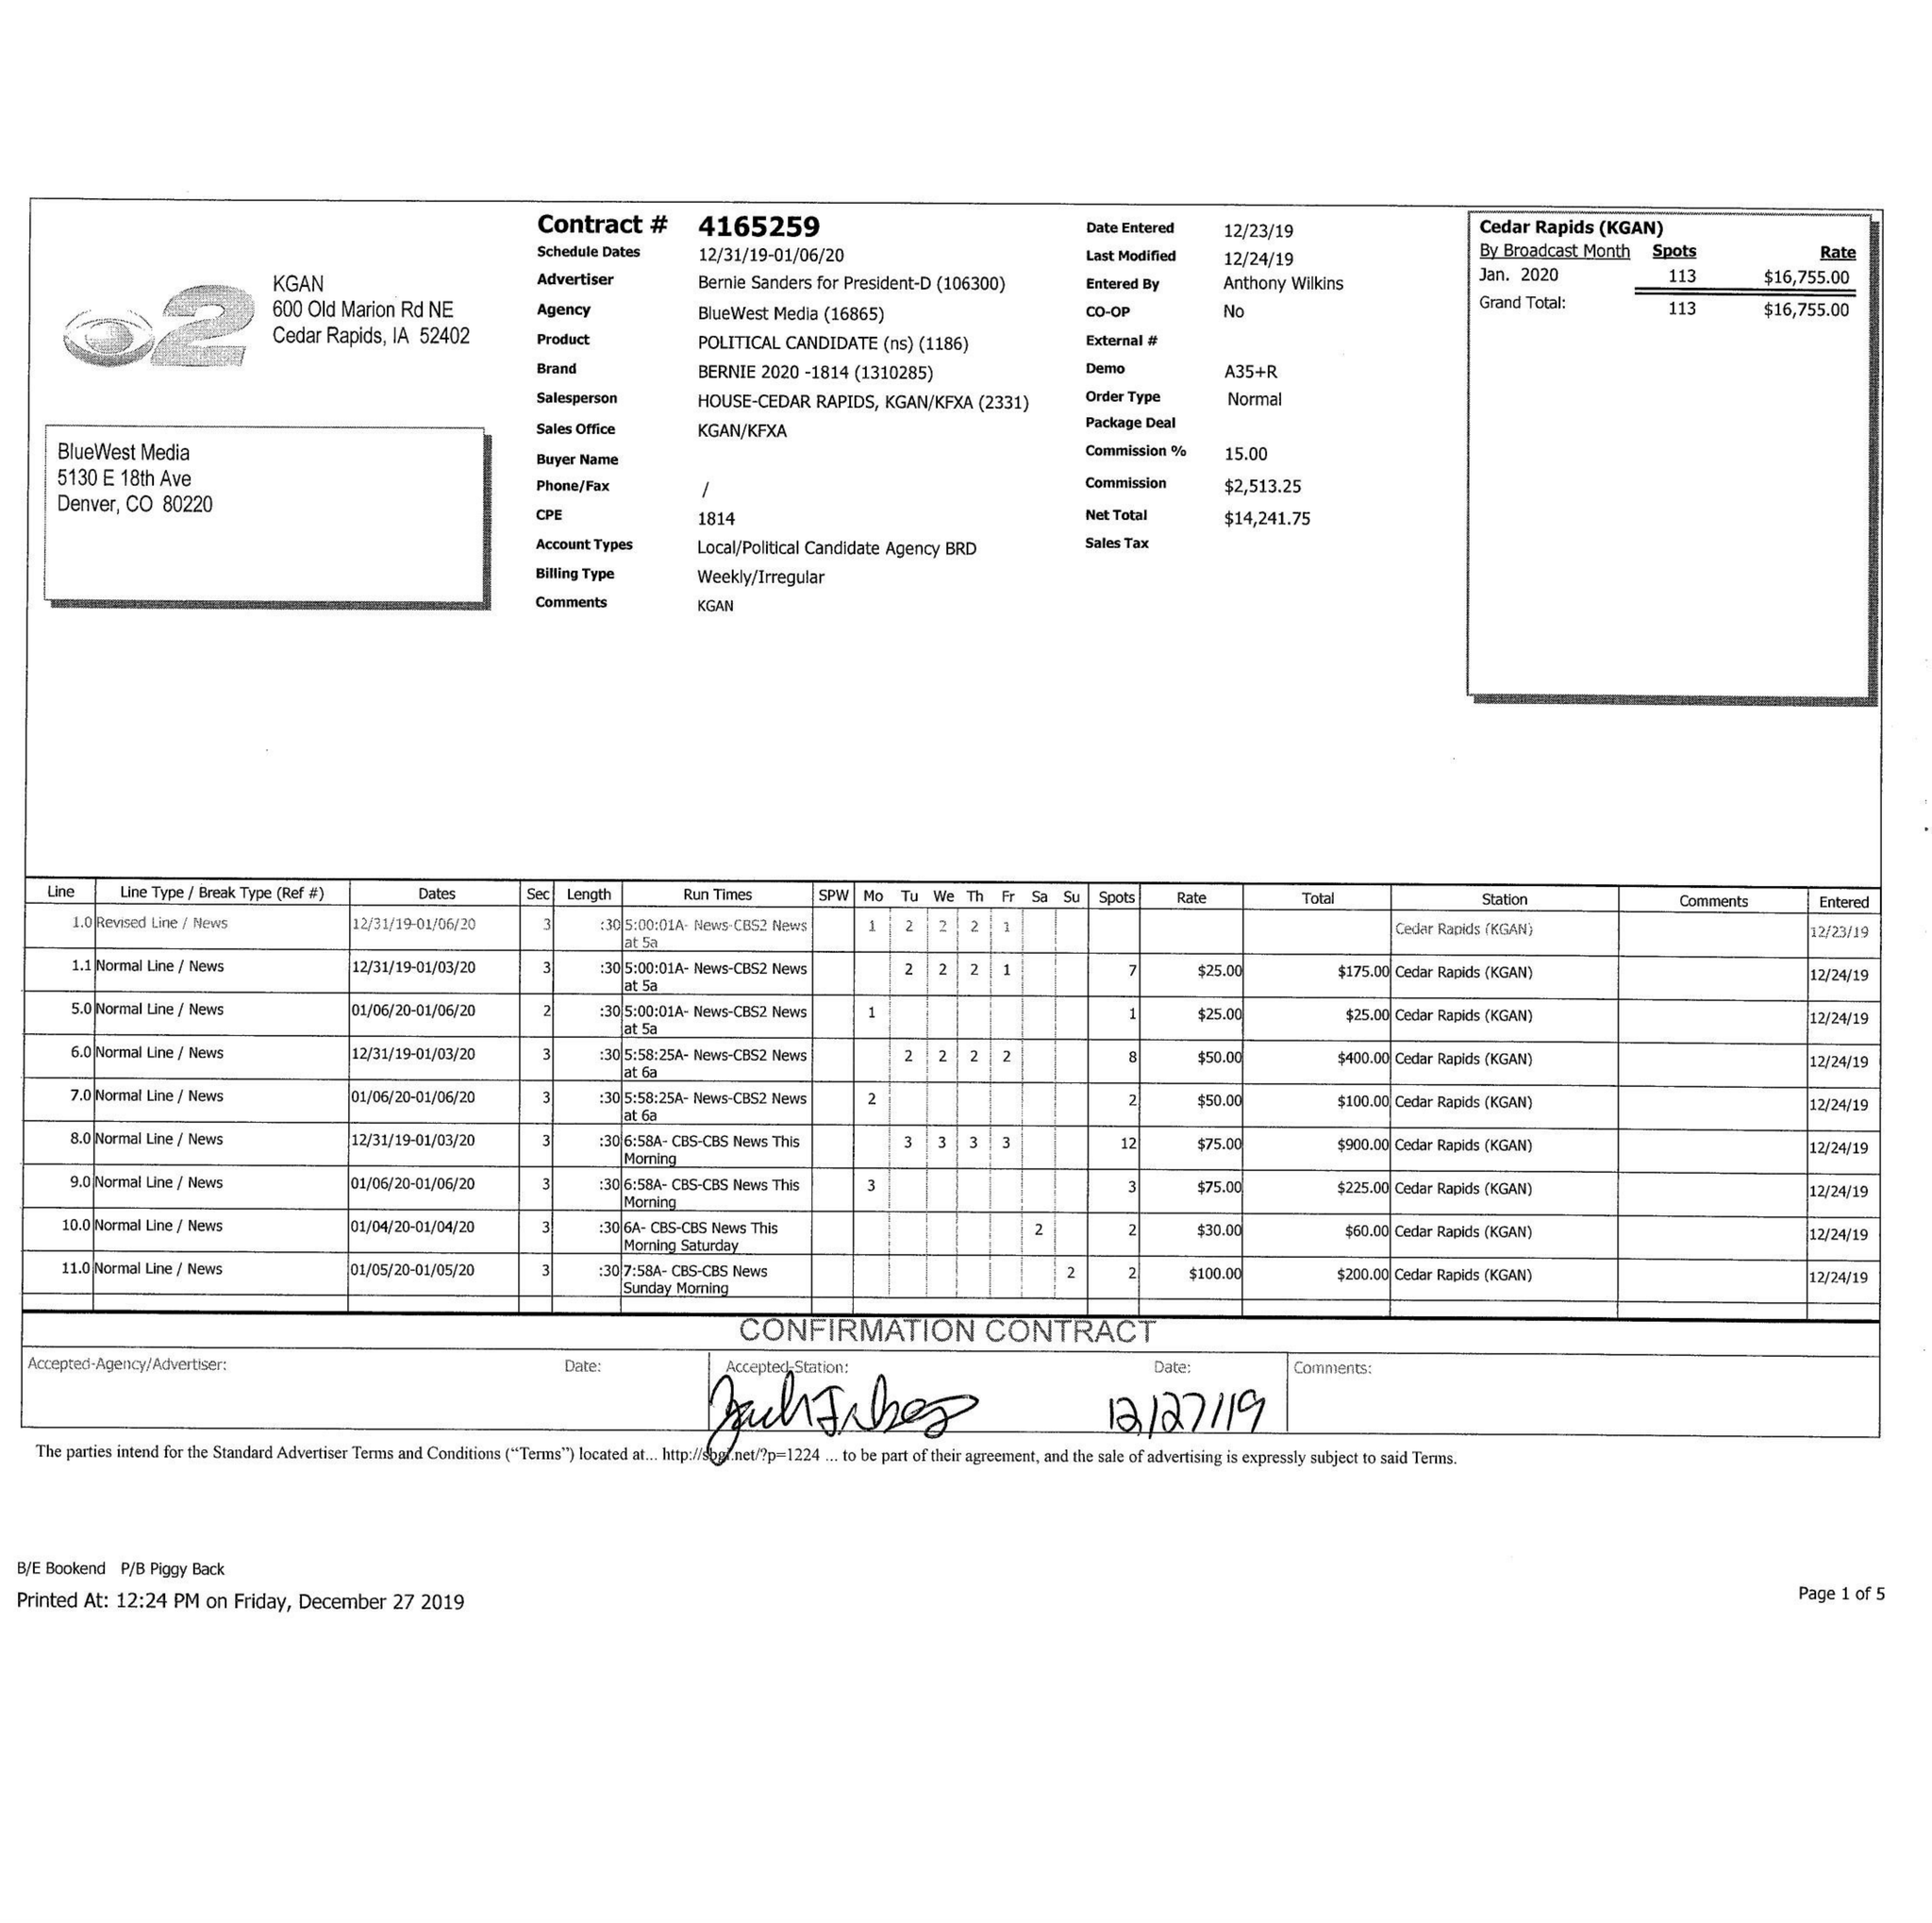What is the value for the advertiser?
Answer the question using a single word or phrase. BERNIE SANDERS FOR PRESIDENT-D 